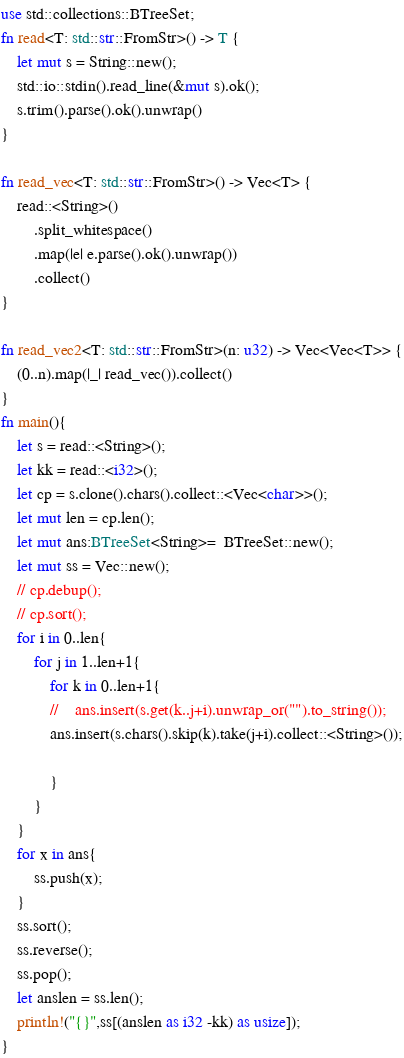<code> <loc_0><loc_0><loc_500><loc_500><_Rust_>use std::collections::BTreeSet;
fn read<T: std::str::FromStr>() -> T {
    let mut s = String::new();
    std::io::stdin().read_line(&mut s).ok();
    s.trim().parse().ok().unwrap()
}

fn read_vec<T: std::str::FromStr>() -> Vec<T> {
    read::<String>()
        .split_whitespace()
        .map(|e| e.parse().ok().unwrap())
        .collect()
}

fn read_vec2<T: std::str::FromStr>(n: u32) -> Vec<Vec<T>> {
    (0..n).map(|_| read_vec()).collect()
}
fn main(){
    let s = read::<String>();
    let kk = read::<i32>();
    let cp = s.clone().chars().collect::<Vec<char>>();
    let mut len = cp.len();
    let mut ans:BTreeSet<String>=  BTreeSet::new();
    let mut ss = Vec::new();
    // cp.debup();
    // cp.sort();
    for i in 0..len{
        for j in 1..len+1{
            for k in 0..len+1{
            //    ans.insert(s.get(k..j+i).unwrap_or("").to_string());
            ans.insert(s.chars().skip(k).take(j+i).collect::<String>());

            }
        }
    }
    for x in ans{
        ss.push(x);
    }
    ss.sort();
    ss.reverse();
    ss.pop();
    let anslen = ss.len();
    println!("{}",ss[(anslen as i32 -kk) as usize]);
}</code> 